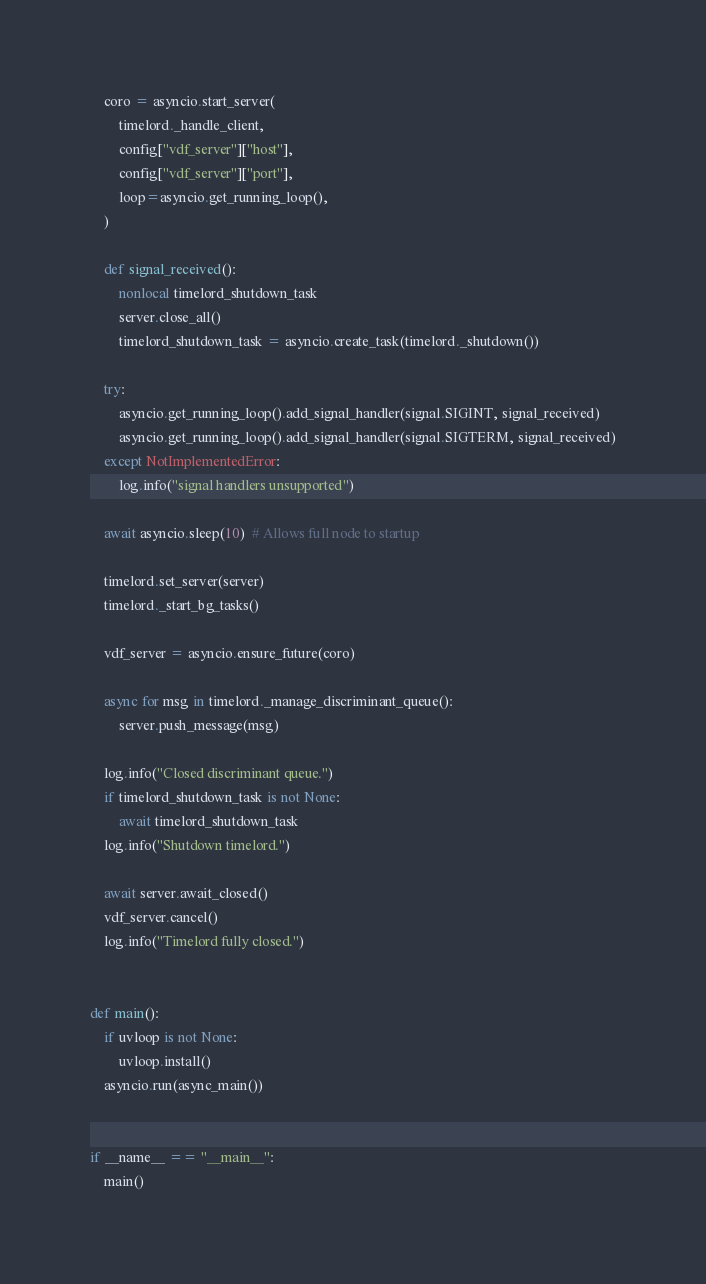<code> <loc_0><loc_0><loc_500><loc_500><_Python_>    coro = asyncio.start_server(
        timelord._handle_client,
        config["vdf_server"]["host"],
        config["vdf_server"]["port"],
        loop=asyncio.get_running_loop(),
    )

    def signal_received():
        nonlocal timelord_shutdown_task
        server.close_all()
        timelord_shutdown_task = asyncio.create_task(timelord._shutdown())

    try:
        asyncio.get_running_loop().add_signal_handler(signal.SIGINT, signal_received)
        asyncio.get_running_loop().add_signal_handler(signal.SIGTERM, signal_received)
    except NotImplementedError:
        log.info("signal handlers unsupported")

    await asyncio.sleep(10)  # Allows full node to startup

    timelord.set_server(server)
    timelord._start_bg_tasks()

    vdf_server = asyncio.ensure_future(coro)

    async for msg in timelord._manage_discriminant_queue():
        server.push_message(msg)

    log.info("Closed discriminant queue.")
    if timelord_shutdown_task is not None:
        await timelord_shutdown_task
    log.info("Shutdown timelord.")

    await server.await_closed()
    vdf_server.cancel()
    log.info("Timelord fully closed.")


def main():
    if uvloop is not None:
        uvloop.install()
    asyncio.run(async_main())


if __name__ == "__main__":
    main()
</code> 